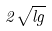Convert formula to latex. <formula><loc_0><loc_0><loc_500><loc_500>2 \sqrt { l g }</formula> 